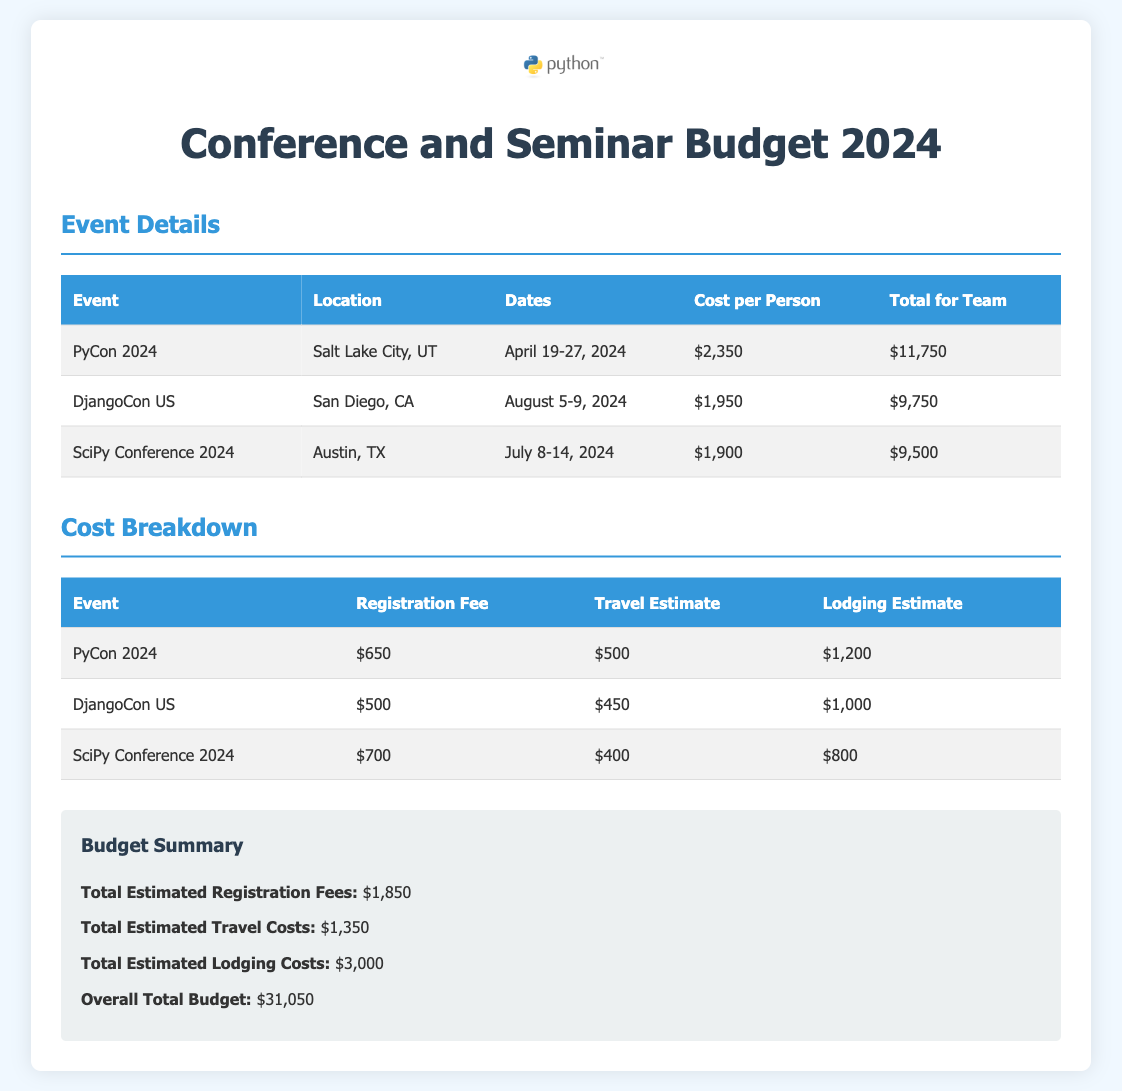What is the total estimated registration fees? The total estimated registration fees are provided in the budget summary section and is the sum of all registration fees for the events listed.
Answer: $1,850 What is the location of PyCon 2024? The location for PyCon 2024 is specified in the event details table under the location column.
Answer: Salt Lake City, UT What are the travel estimates for DjangoCon US? The travel estimate for DjangoCon US can be found in the cost breakdown table under the travel estimate column.
Answer: $450 What are the dates for the SciPy Conference 2024? The dates for SciPy Conference 2024 are listed in the event details table in the dates column.
Answer: July 8-14, 2024 What is the overall total budget? The overall total budget is summarized at the end of the document and combines all estimated costs.
Answer: $31,050 What is the lodging estimate for PyCon 2024? The lodging estimate for PyCon 2024 is available in the cost breakdown table under the lodging estimate column.
Answer: $1,200 Which event has the highest cost per person? To find the event with the highest cost per person, compare the values listed in the cost per person column of the event details table.
Answer: PyCon 2024 How much is allocated for lodging in total? The total allocated for lodging can be calculated by summing the lodging estimates across all events listed in the cost breakdown table.
Answer: $3,000 What is the registration fee for the SciPy Conference 2024? The registration fee for the SciPy Conference 2024 is provided in the cost breakdown table under the registration fee column.
Answer: $700 